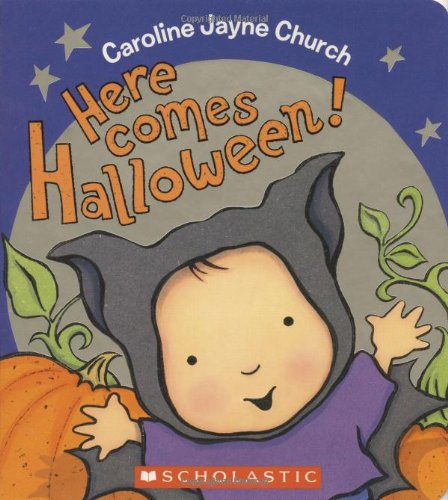What type of activities might be illustrated within this book, given its title and cover design? The book likely includes illustrations of typical Halloween activities such as pumpkin carving, trick-or-treating, and costume parties, all tailored to engage and entertain young readers. 